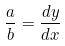<formula> <loc_0><loc_0><loc_500><loc_500>\frac { a } { b } = \frac { d y } { d x }</formula> 